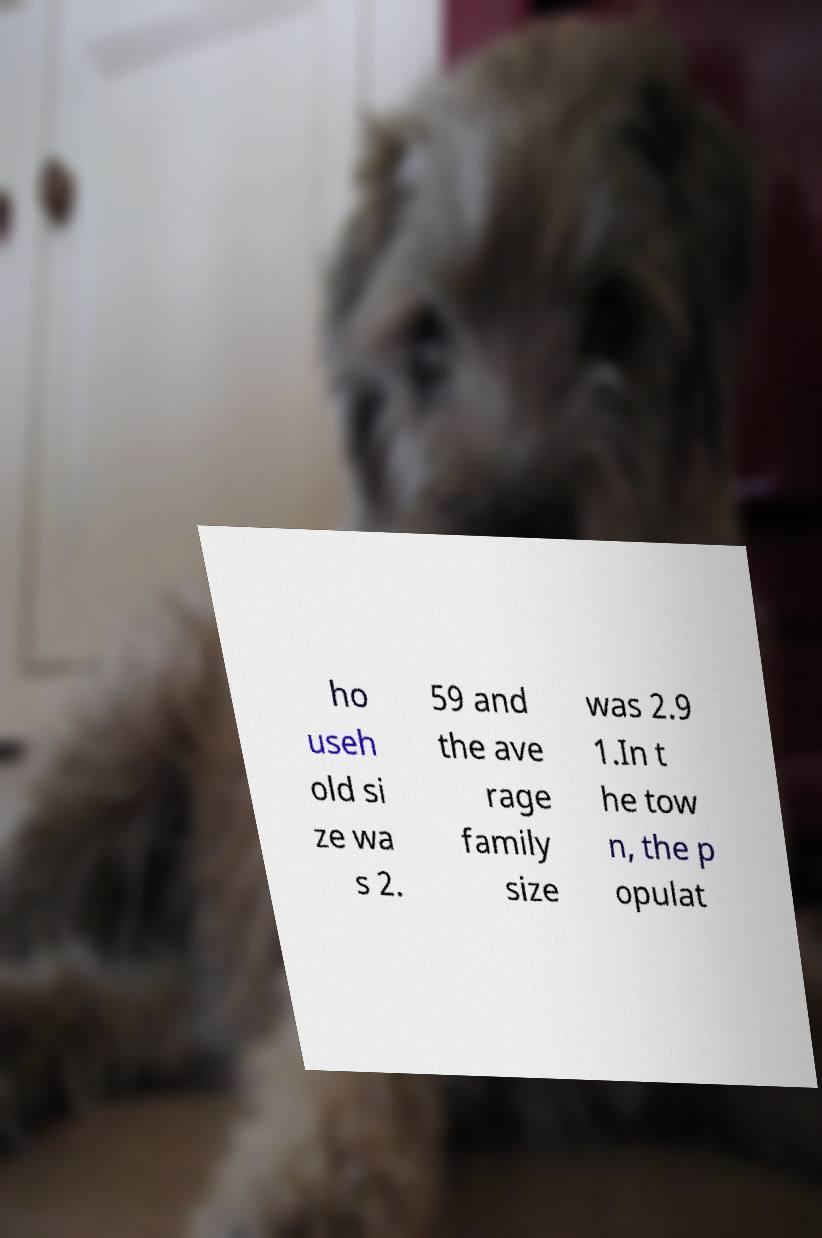Can you read and provide the text displayed in the image?This photo seems to have some interesting text. Can you extract and type it out for me? ho useh old si ze wa s 2. 59 and the ave rage family size was 2.9 1.In t he tow n, the p opulat 